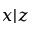Convert formula to latex. <formula><loc_0><loc_0><loc_500><loc_500>x | z</formula> 